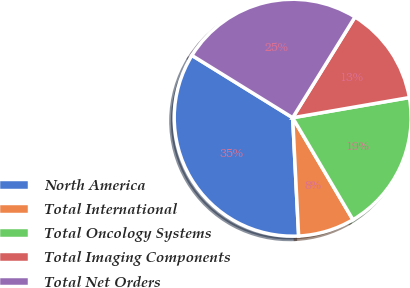Convert chart to OTSL. <chart><loc_0><loc_0><loc_500><loc_500><pie_chart><fcel>North America<fcel>Total International<fcel>Total Oncology Systems<fcel>Total Imaging Components<fcel>Total Net Orders<nl><fcel>34.62%<fcel>7.69%<fcel>19.23%<fcel>13.46%<fcel>25.0%<nl></chart> 